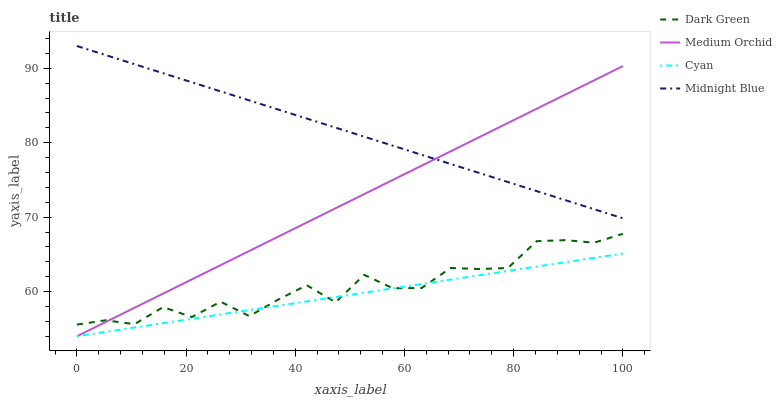Does Cyan have the minimum area under the curve?
Answer yes or no. Yes. Does Midnight Blue have the maximum area under the curve?
Answer yes or no. Yes. Does Medium Orchid have the minimum area under the curve?
Answer yes or no. No. Does Medium Orchid have the maximum area under the curve?
Answer yes or no. No. Is Cyan the smoothest?
Answer yes or no. Yes. Is Dark Green the roughest?
Answer yes or no. Yes. Is Medium Orchid the smoothest?
Answer yes or no. No. Is Medium Orchid the roughest?
Answer yes or no. No. Does Cyan have the lowest value?
Answer yes or no. Yes. Does Midnight Blue have the lowest value?
Answer yes or no. No. Does Midnight Blue have the highest value?
Answer yes or no. Yes. Does Medium Orchid have the highest value?
Answer yes or no. No. Is Dark Green less than Midnight Blue?
Answer yes or no. Yes. Is Midnight Blue greater than Dark Green?
Answer yes or no. Yes. Does Medium Orchid intersect Cyan?
Answer yes or no. Yes. Is Medium Orchid less than Cyan?
Answer yes or no. No. Is Medium Orchid greater than Cyan?
Answer yes or no. No. Does Dark Green intersect Midnight Blue?
Answer yes or no. No. 